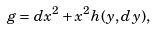<formula> <loc_0><loc_0><loc_500><loc_500>g = d x ^ { 2 } + x ^ { 2 } h ( y , d y ) ,</formula> 